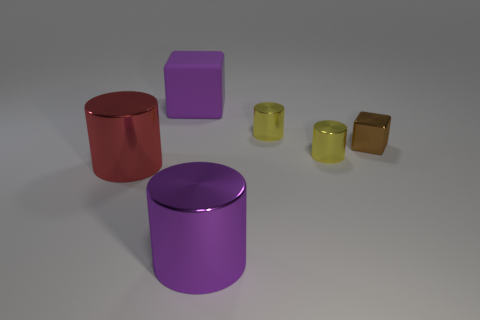Add 4 red cylinders. How many objects exist? 10 Subtract all cubes. How many objects are left? 4 Add 2 tiny yellow metal objects. How many tiny yellow metal objects are left? 4 Add 1 blocks. How many blocks exist? 3 Subtract 0 green blocks. How many objects are left? 6 Subtract all big blocks. Subtract all yellow objects. How many objects are left? 3 